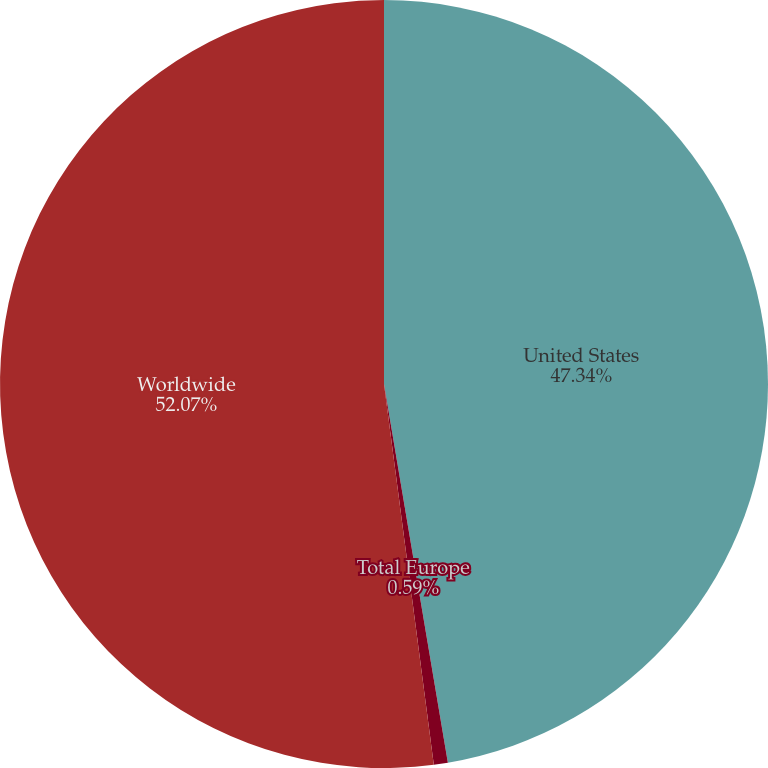Convert chart. <chart><loc_0><loc_0><loc_500><loc_500><pie_chart><fcel>United States<fcel>Total Europe<fcel>Worldwide<nl><fcel>47.34%<fcel>0.59%<fcel>52.07%<nl></chart> 